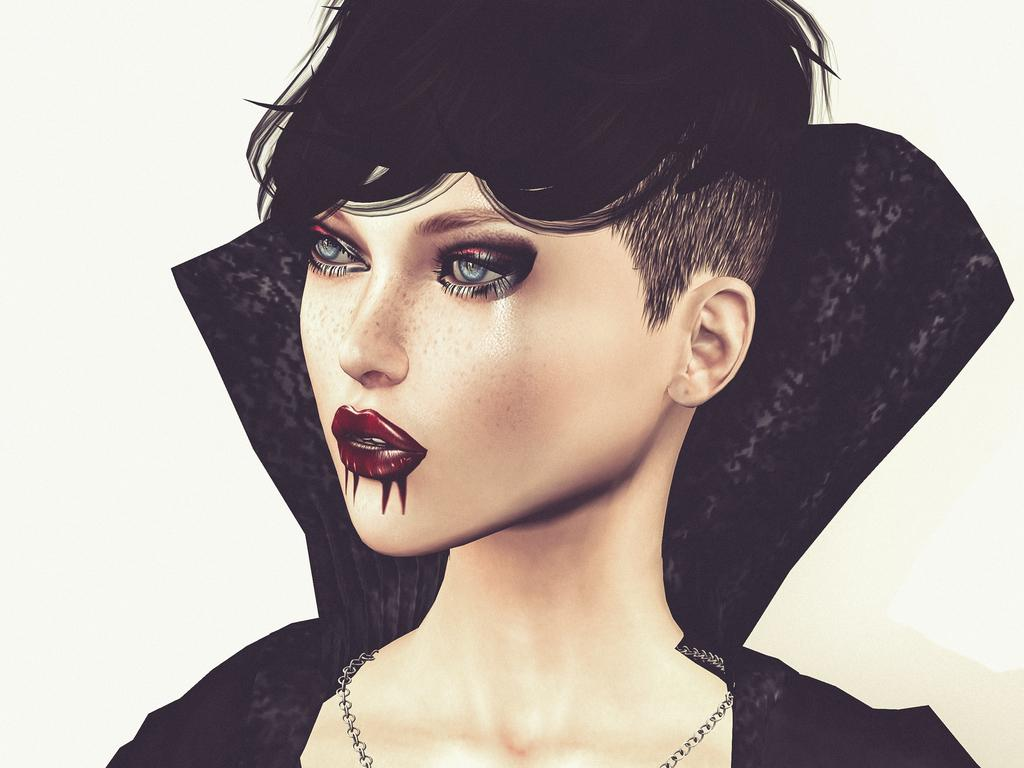What is the main subject of the image? There is an animated picture of a lady in the image. Where is the animated picture of the lady located in the image? The animated picture of the lady is in the center of the image. How many sticks are visible in the image? There are no sticks present in the image. What type of store is depicted in the image? There is no store depicted in the image; it features an animated picture of a lady. 